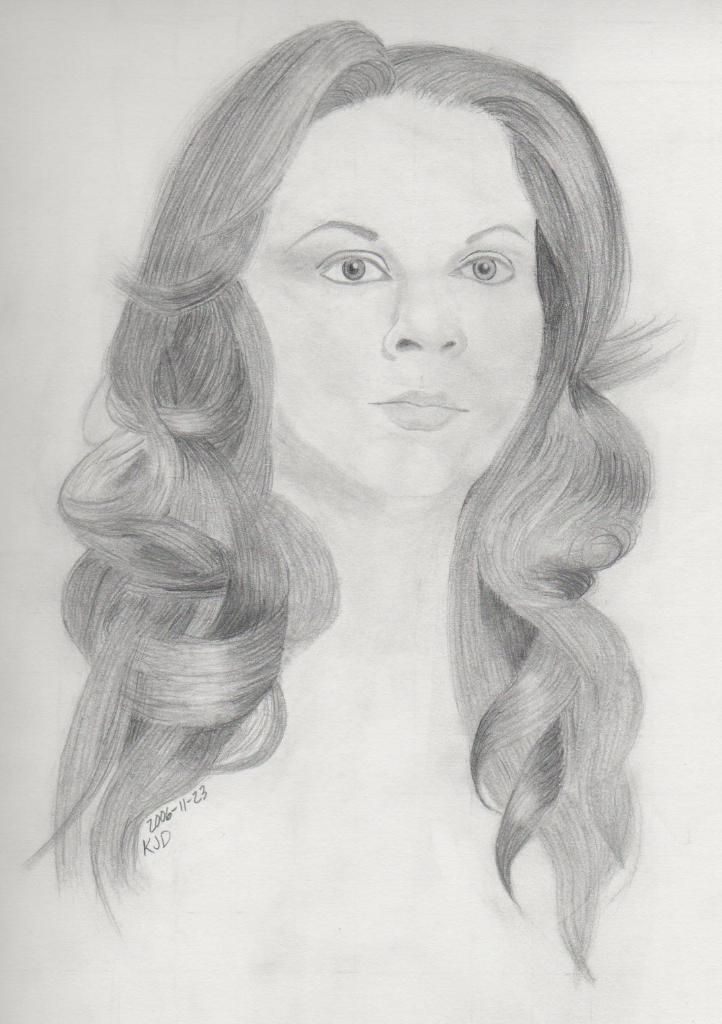What is depicted in the image? There is a drawing of a lady in the image. Can you describe the lady's appearance? The lady has curly hair. Are there any words or text on the drawing? Yes, there is writing on the drawing. What type of apparel is the lady wearing in the image? The provided facts do not mention any apparel worn by the lady in the drawing. Can you tell me what kind of straw is used for the soup in the image? There is no soup or straw present in the image; it features a drawing of a lady with curly hair and writing on it. 